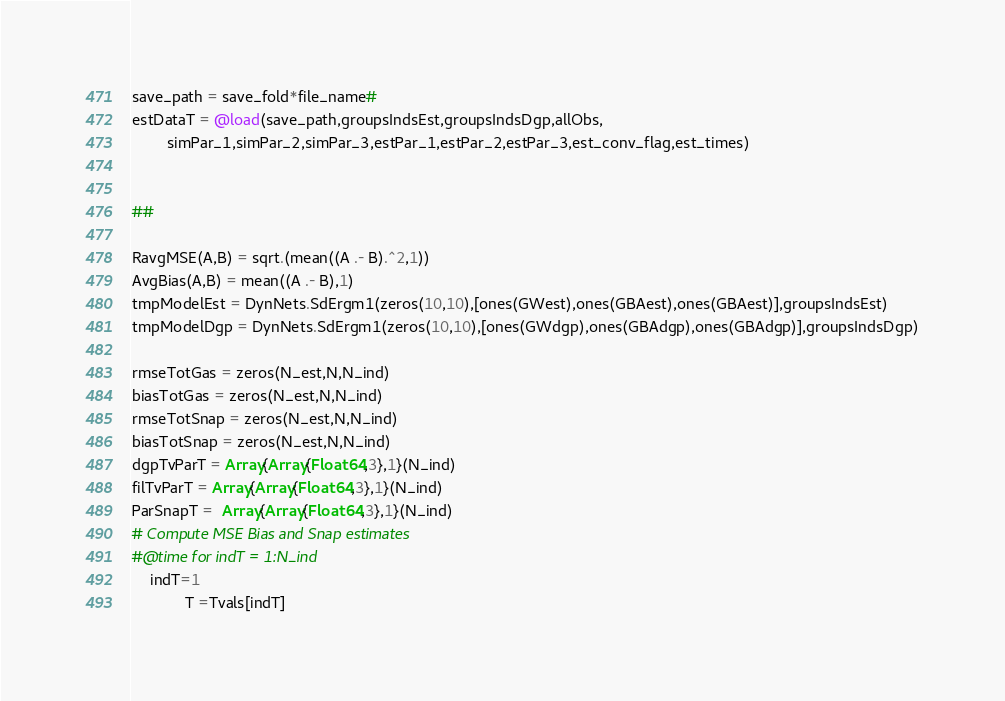<code> <loc_0><loc_0><loc_500><loc_500><_Julia_>save_path = save_fold*file_name#
estDataT = @load(save_path,groupsIndsEst,groupsIndsDgp,allObs,
        simPar_1,simPar_2,simPar_3,estPar_1,estPar_2,estPar_3,est_conv_flag,est_times)


##

RavgMSE(A,B) = sqrt.(mean((A .- B).^2,1))
AvgBias(A,B) = mean((A .- B),1)
tmpModelEst = DynNets.SdErgm1(zeros(10,10),[ones(GWest),ones(GBAest),ones(GBAest)],groupsIndsEst)
tmpModelDgp = DynNets.SdErgm1(zeros(10,10),[ones(GWdgp),ones(GBAdgp),ones(GBAdgp)],groupsIndsDgp)

rmseTotGas = zeros(N_est,N,N_ind)
biasTotGas = zeros(N_est,N,N_ind)
rmseTotSnap = zeros(N_est,N,N_ind)
biasTotSnap = zeros(N_est,N,N_ind)
dgpTvParT = Array{Array{Float64,3},1}(N_ind)
filTvParT = Array{Array{Float64,3},1}(N_ind)
ParSnapT =  Array{Array{Float64,3},1}(N_ind)
# Compute MSE Bias and Snap estimates
#@time for indT = 1:N_ind
    indT=1
            T =Tvals[indT]</code> 